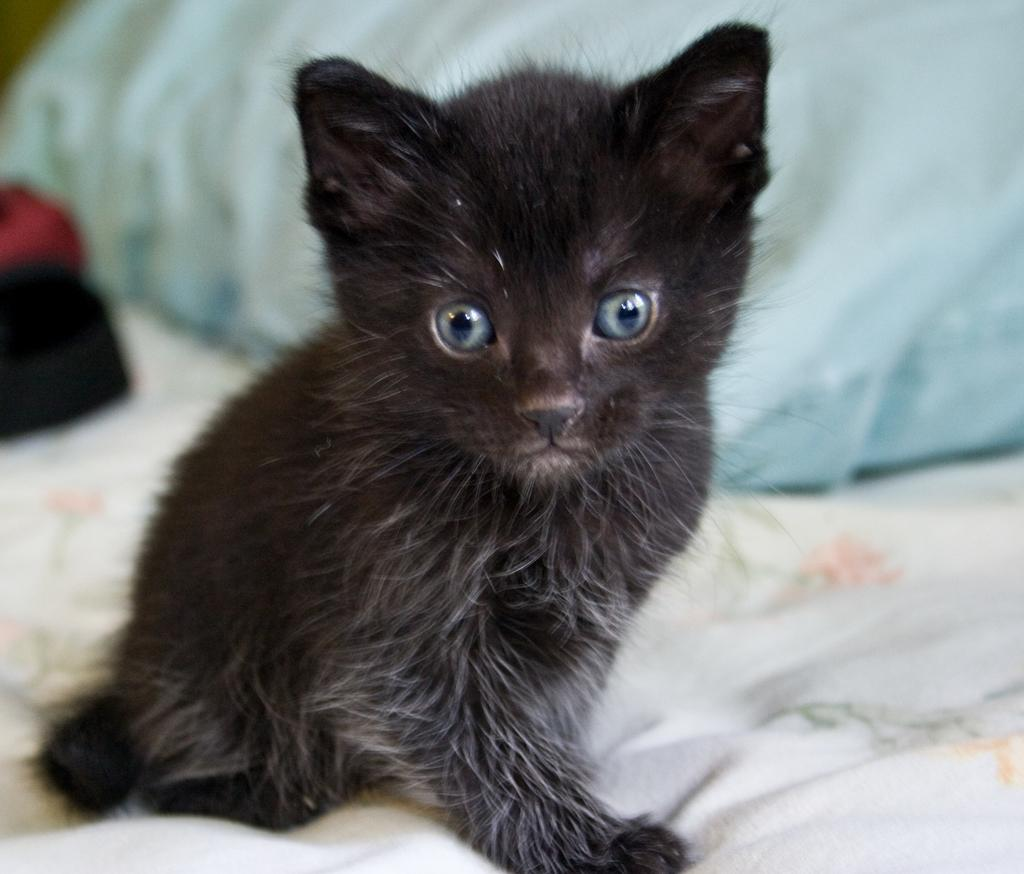What is the main subject in the center of the image? There is a cat in the center of the image. What piece of furniture is located at the bottom of the image? There is a bed at the bottom of the image. What item is used for support or comfort while sleeping? There is a pillow in the image. What type of personal items can be seen in the image? There are clothes visible in the image. How many dinosaurs are visible in the image? There are no dinosaurs present in the image. What is the cat doing on the moon in the image? The image does not depict the cat on the moon; it is on a bed. 